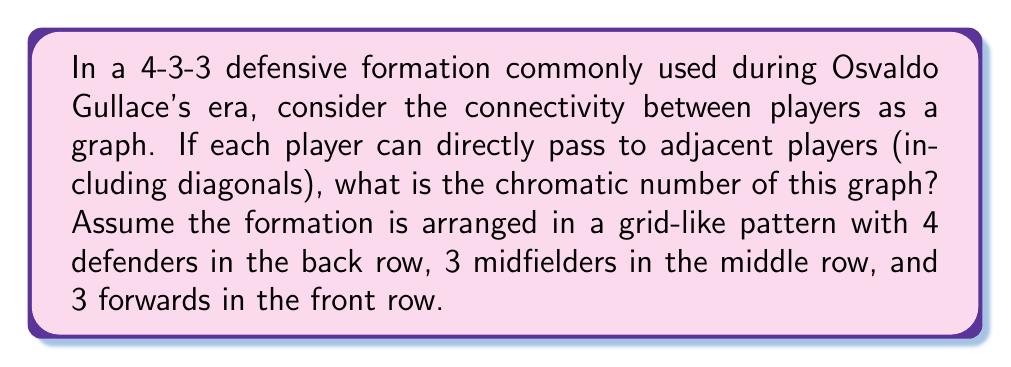Give your solution to this math problem. To solve this problem, we'll follow these steps:

1) First, let's visualize the 4-3-3 formation as a graph:

[asy]
unitsize(1cm);
pair[] p = {(0,0),(1,0),(2,0),(3,0),(0.5,1),(1.5,1),(2.5,1),(0,2),(1.5,2),(3,2)};
for(int i=0; i<10; ++i) {
  fill(p[i], circle(0.2));
  label(string(i+1), p[i]);
}
for(int i=0; i<10; ++i) {
  for(int j=i+1; j<10; ++j) {
    if(length(p[i]-p[j]) <= sqrt(2)+0.01) {
      draw(p[i]--p[j]);
    }
  }
}
[/asy]

2) In graph theory, the chromatic number is the minimum number of colors needed to color the vertices of a graph so that no two adjacent vertices share the same color.

3) To determine the chromatic number, we need to analyze the maximum degree of the graph (the highest number of connections any single node has):
   - Corner defenders (1 and 4) connect to 3 other players
   - Central defenders (2 and 3) connect to 5 other players
   - Side midfielders (5 and 7) connect to 5 other players
   - Central midfielder (6) connects to 8 other players
   - Forwards (8, 9, 10) connect to 3-5 other players

4) The maximum degree is 8, occurring at the central midfielder position.

5) According to Brooks' theorem, for any connected undirected graph G with maximum degree Δ, the chromatic number χ(G) is at most Δ, unless G is a complete graph or an odd cycle, in which case the chromatic number is Δ + 1.

6) Our graph is neither a complete graph nor an odd cycle, so the chromatic number is at most equal to the maximum degree, which is 8.

7) However, we can actually color this graph with fewer colors. By careful assignment, we can color the graph with 4 colors:
   - Color 1: players 1, 6, 10
   - Color 2: players 2, 7, 8
   - Color 3: players 3, 5, 9
   - Color 4: player 4

8) No two adjacent vertices share the same color with this arrangement, and we cannot reduce the number of colors further without creating conflicts.

Therefore, the chromatic number of this graph is 4.
Answer: The chromatic number of the graph representing the 4-3-3 formation is 4. 